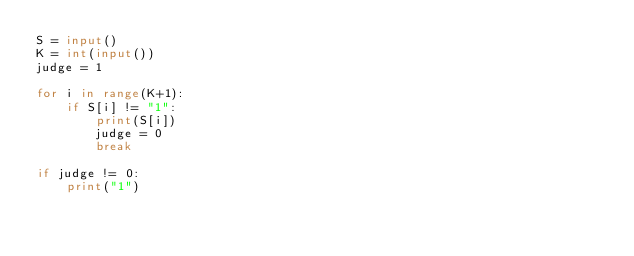Convert code to text. <code><loc_0><loc_0><loc_500><loc_500><_Python_>S = input()
K = int(input())
judge = 1

for i in range(K+1):
    if S[i] != "1":
        print(S[i])
        judge = 0
        break

if judge != 0:
    print("1")</code> 